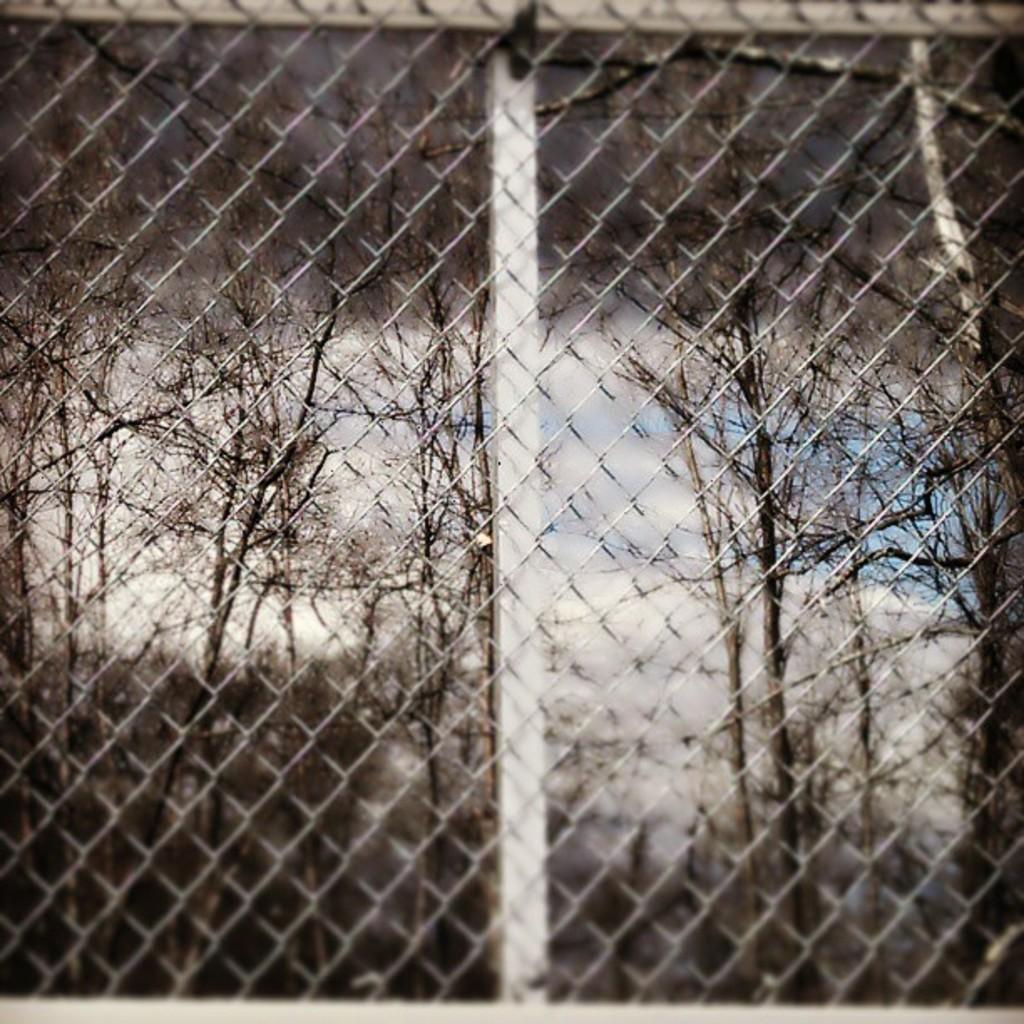What type of vegetation can be seen in the image? There are bare trees visible in the image. What is the condition of the sky in the image? The sky appears to be cloudy in the image. What kind of structure is present in the image? There is a mesh or barrier in the image. What can be seen behind the mesh? There is a rod visible behind the mesh. What type of hat is hanging on the rod in the image? There is no hat present in the image; only bare trees, a cloudy sky, a mesh or barrier, and a rod are visible. 